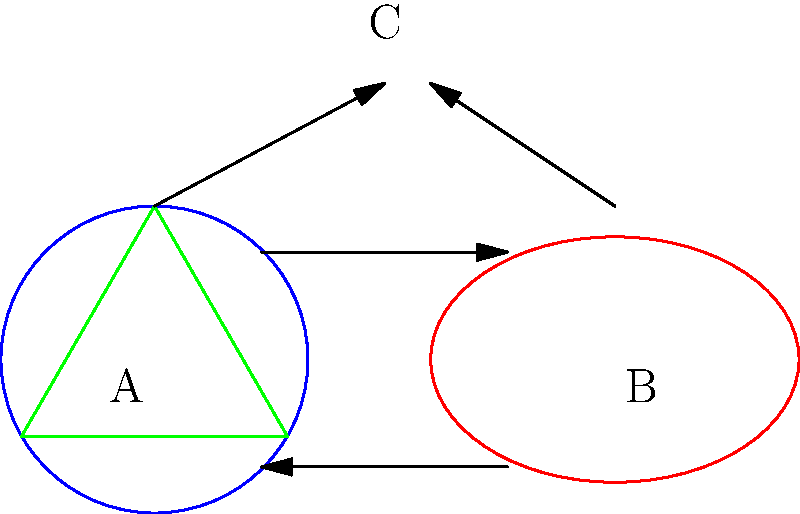Consider the energy system configurations represented by shapes A (circular solar panel), B (elliptical solar panel), and C (triangular wind turbine). Which of the following statements about the homeomorphism between these configurations is correct?

1) A and B are homeomorphic, but C is not homeomorphic to either A or B
2) A, B, and C are all homeomorphic to each other
3) Only A and C are homeomorphic
4) A, B, and C are all topologically distinct To determine the homeomorphism between the energy system configurations, we need to consider their topological properties:

1) First, let's examine shapes A and B:
   - A is a circular solar panel (topologically equivalent to a circle)
   - B is an elliptical solar panel (also topologically equivalent to a circle)
   - Circles and ellipses are homeomorphic as they can be continuously deformed into each other without cutting or gluing

2) Now, let's consider shape C (triangular wind turbine):
   - C is topologically equivalent to a circle as well, since any simple closed curve without self-intersections is homeomorphic to a circle

3) The key topological property here is that all three shapes are simple closed curves without holes or self-intersections

4) In topology, the precise shape (circular, elliptical, or triangular) doesn't matter; what matters is the fundamental structure (in this case, a simple closed curve)

5) Therefore, all three shapes (A, B, and C) are homeomorphic to each other, as they can all be continuously deformed into one another without cutting or gluing

Based on this analysis, the correct statement is that A, B, and C are all homeomorphic to each other.
Answer: A, B, and C are all homeomorphic to each other 